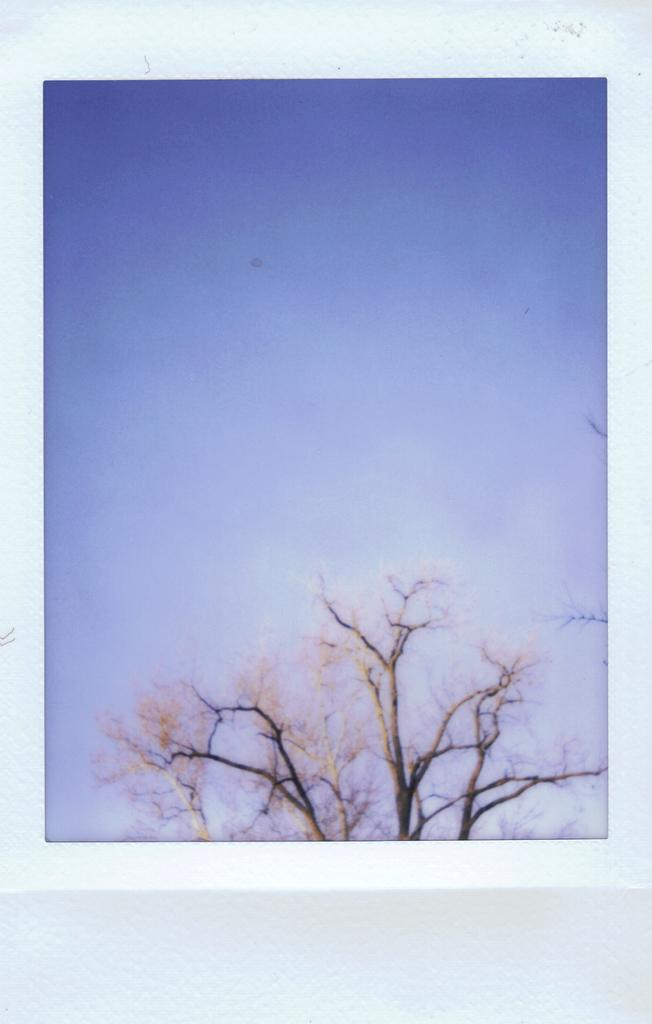What type of tree is in the image? There is a bare tree in the image. What else can be seen in the image besides the tree? The sky is visible in the image. What color is the sky in the image? The sky is blue in color. What type of wine is being served at the business meeting in the image? There is no business meeting or wine present in the image; it features a bare tree and a blue sky. 